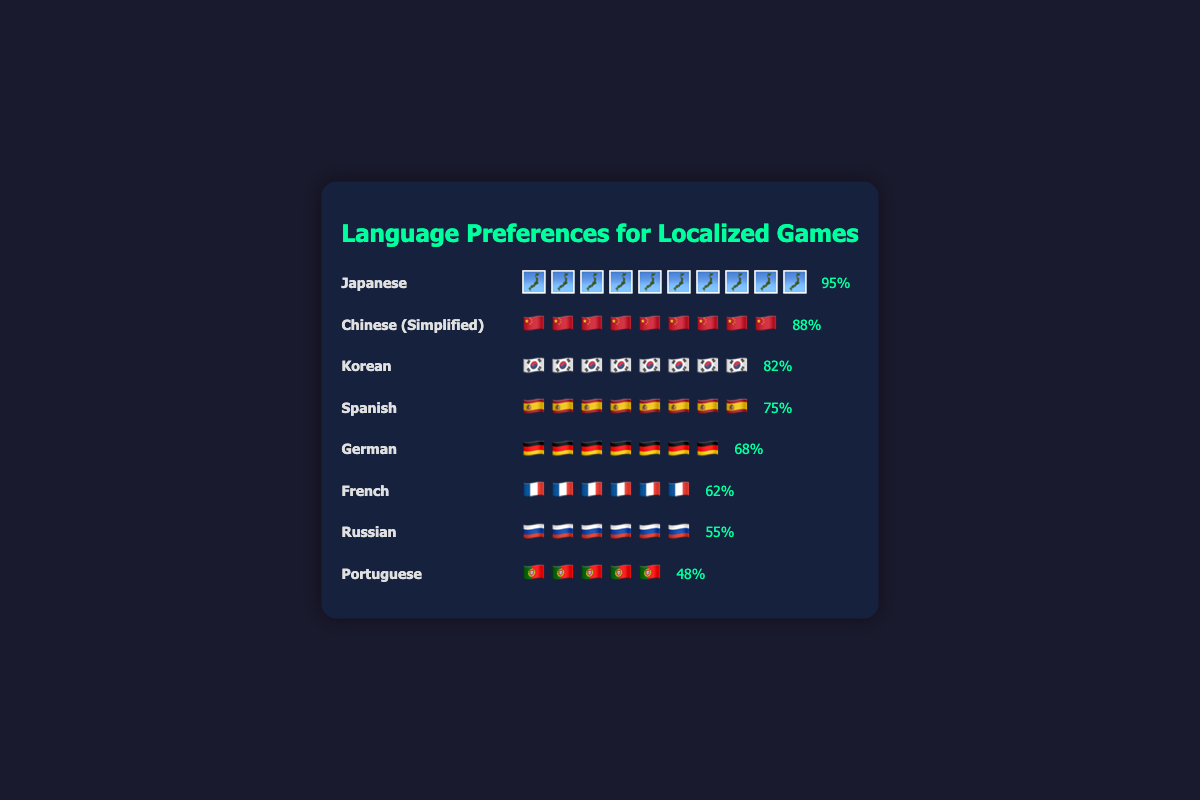What is the title of the figure? The title is displayed at the top of the figure. It reads "Language Preferences for Localized Games".
Answer: Language Preferences for Localized Games Which language has the highest preference score? The figure shows each language along with icons representing their preference score. The language with the most icons is Japanese, indicating it has the highest preference score.
Answer: Japanese What is the preference score for French? In the figure, each language has its preference score displayed next to its icons. The preference score for French is labeled as 62%.
Answer: 62% How many languages have a preference score higher than 70%? By looking at the preference scores displayed next to the icons, we can count the languages with scores over 70%. These are Japanese, Chinese (Simplified), Korean, and Spanish, making a total of 4.
Answer: 4 What is the average preference score for the listed languages? Calculate the average by summing up all the preference scores and dividing by the number of languages: (95 + 88 + 82 + 75 + 68 + 62 + 55 + 48) / 8 = 573 / 8 = 71.625.
Answer: 71.625 How does the preference score of Russian compare to that of German? The preference score is displayed next to each language. Russian has a score of 55%, and German has 68%. Comparing these, German has a higher preference score than Russian.
Answer: German has a higher score than Russian What is the total number of icons for all languages combined? Count the icons for each language and sum them up. Japanese has 10 icons, Chinese (Simplified) has 9, Korean has 8, Spanish has 7, German has 6, French has 6, Russian has 6, and Portuguese has 5. The total is 10 + 9 + 8 + 7 + 6 + 6 + 6 + 5 = 57.
Answer: 57 Which languages have fewer icons than English (assuming English score is 65)? There is no English shown, but for comparison, any language with fewer than 65% will have fewer icons (6 or fewer icons). These are French, Russian, and Portuguese.
Answer: French, Russian, Portuguese What is the difference in preference scores between the highest and lowest languages? The highest preference score is for Japanese (95%) and the lowest is for Portuguese (48%). The difference is 95 - 48 = 47.
Answer: 47 How many languages have a preference score between 60% and 80%? By reviewing the scores, the languages with preference scores between 60% and 80% are Spanish (75), German (68), and French (62), making a total of 3.
Answer: 3 